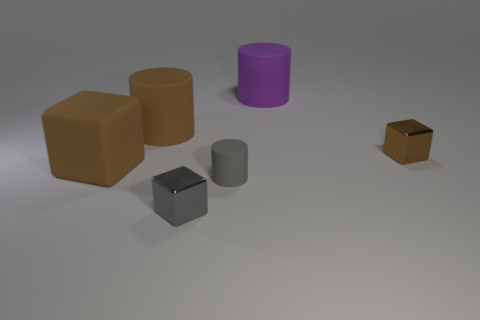Subtract all purple cylinders. How many cylinders are left? 2 Add 3 small cyan metal blocks. How many objects exist? 9 Subtract all gray spheres. How many brown cubes are left? 2 Subtract all gray blocks. How many blocks are left? 2 Subtract 1 blocks. How many blocks are left? 2 Subtract all blue cylinders. Subtract all blue spheres. How many cylinders are left? 3 Subtract all gray rubber cylinders. Subtract all small cubes. How many objects are left? 3 Add 1 matte cylinders. How many matte cylinders are left? 4 Add 5 brown cylinders. How many brown cylinders exist? 6 Subtract 0 yellow blocks. How many objects are left? 6 